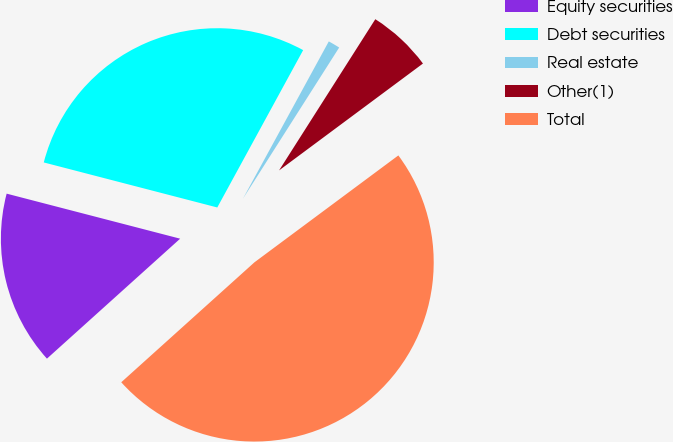Convert chart to OTSL. <chart><loc_0><loc_0><loc_500><loc_500><pie_chart><fcel>Equity securities<fcel>Debt securities<fcel>Real estate<fcel>Other(1)<fcel>Total<nl><fcel>15.71%<fcel>28.91%<fcel>1.07%<fcel>5.81%<fcel>48.5%<nl></chart> 